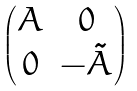<formula> <loc_0><loc_0><loc_500><loc_500>\begin{pmatrix} A & 0 \\ 0 & - \tilde { A } \end{pmatrix}</formula> 